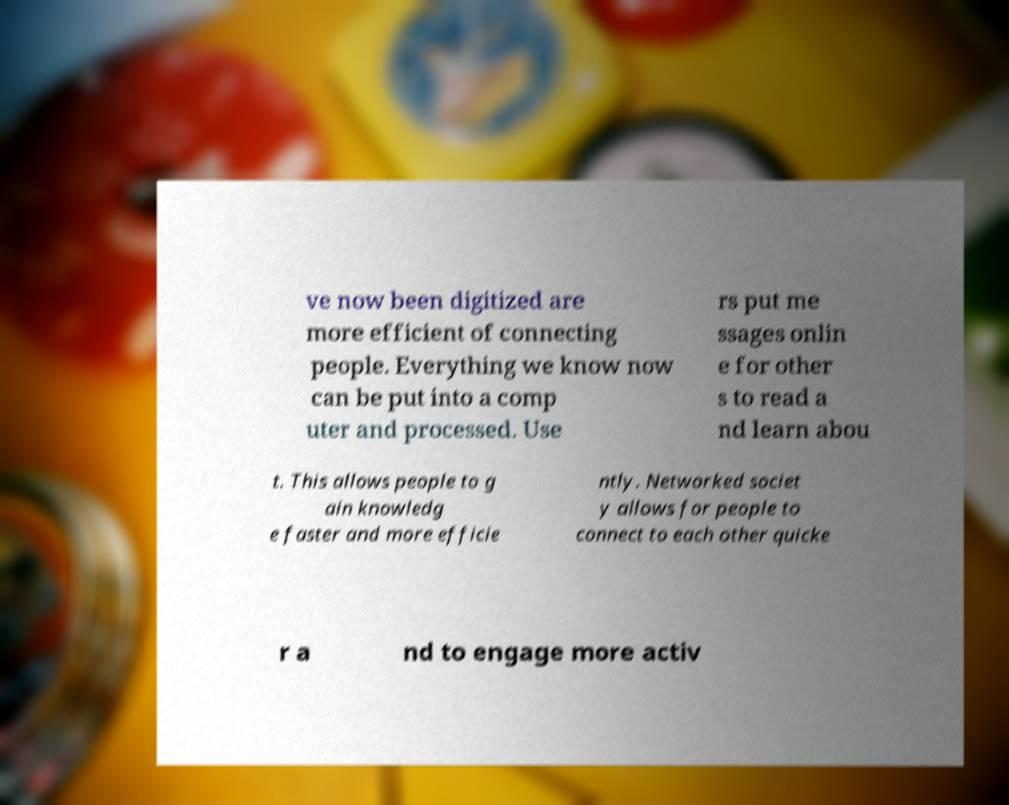Can you accurately transcribe the text from the provided image for me? ve now been digitized are more efficient of connecting people. Everything we know now can be put into a comp uter and processed. Use rs put me ssages onlin e for other s to read a nd learn abou t. This allows people to g ain knowledg e faster and more efficie ntly. Networked societ y allows for people to connect to each other quicke r a nd to engage more activ 